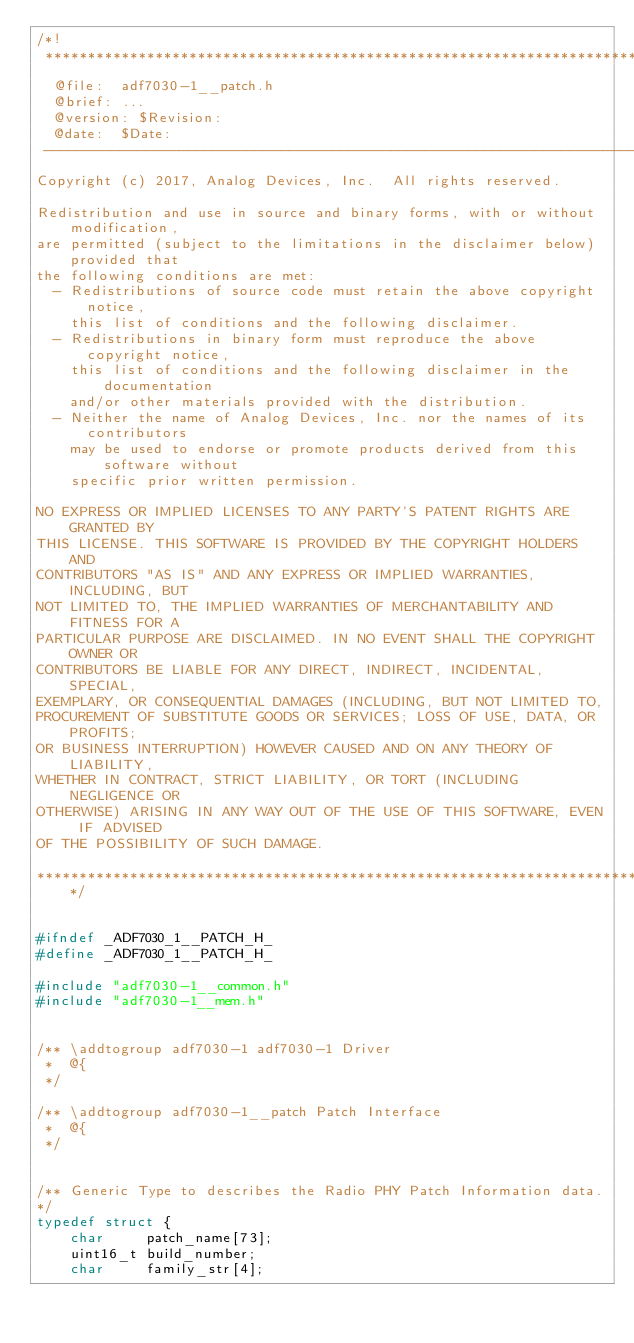Convert code to text. <code><loc_0><loc_0><loc_500><loc_500><_C_>/*!
 *****************************************************************************
  @file:	adf7030-1__patch.h 
  @brief:	...  
  @version:	$Revision: 
  @date:	$Date:
 -----------------------------------------------------------------------------
Copyright (c) 2017, Analog Devices, Inc.  All rights reserved.

Redistribution and use in source and binary forms, with or without modification,
are permitted (subject to the limitations in the disclaimer below) provided that
the following conditions are met:
  - Redistributions of source code must retain the above copyright notice, 
    this list of conditions and the following disclaimer.
  - Redistributions in binary form must reproduce the above copyright notice,
    this list of conditions and the following disclaimer in the documentation 
    and/or other materials provided with the distribution.
  - Neither the name of Analog Devices, Inc. nor the names of its contributors 
    may be used to endorse or promote products derived from this software without
    specific prior written permission.

NO EXPRESS OR IMPLIED LICENSES TO ANY PARTY'S PATENT RIGHTS ARE GRANTED BY 
THIS LICENSE. THIS SOFTWARE IS PROVIDED BY THE COPYRIGHT HOLDERS AND 
CONTRIBUTORS "AS IS" AND ANY EXPRESS OR IMPLIED WARRANTIES, INCLUDING, BUT 
NOT LIMITED TO, THE IMPLIED WARRANTIES OF MERCHANTABILITY AND FITNESS FOR A 
PARTICULAR PURPOSE ARE DISCLAIMED. IN NO EVENT SHALL THE COPYRIGHT OWNER OR 
CONTRIBUTORS BE LIABLE FOR ANY DIRECT, INDIRECT, INCIDENTAL, SPECIAL, 
EXEMPLARY, OR CONSEQUENTIAL DAMAGES (INCLUDING, BUT NOT LIMITED TO, 
PROCUREMENT OF SUBSTITUTE GOODS OR SERVICES; LOSS OF USE, DATA, OR PROFITS; 
OR BUSINESS INTERRUPTION) HOWEVER CAUSED AND ON ANY THEORY OF LIABILITY,
WHETHER IN CONTRACT, STRICT LIABILITY, OR TORT (INCLUDING NEGLIGENCE OR 
OTHERWISE) ARISING IN ANY WAY OUT OF THE USE OF THIS SOFTWARE, EVEN IF ADVISED 
OF THE POSSIBILITY OF SUCH DAMAGE.

*****************************************************************************/


#ifndef _ADF7030_1__PATCH_H_
#define _ADF7030_1__PATCH_H_

#include "adf7030-1__common.h"
#include "adf7030-1__mem.h"


/** \addtogroup adf7030-1 adf7030-1 Driver
 *  @{
 */

/** \addtogroup adf7030-1__patch Patch Interface
 *  @{
 */


/** Generic Type to describes the Radio PHY Patch Information data.
*/
typedef struct {
    char     patch_name[73];
    uint16_t build_number;
    char     family_str[4];</code> 